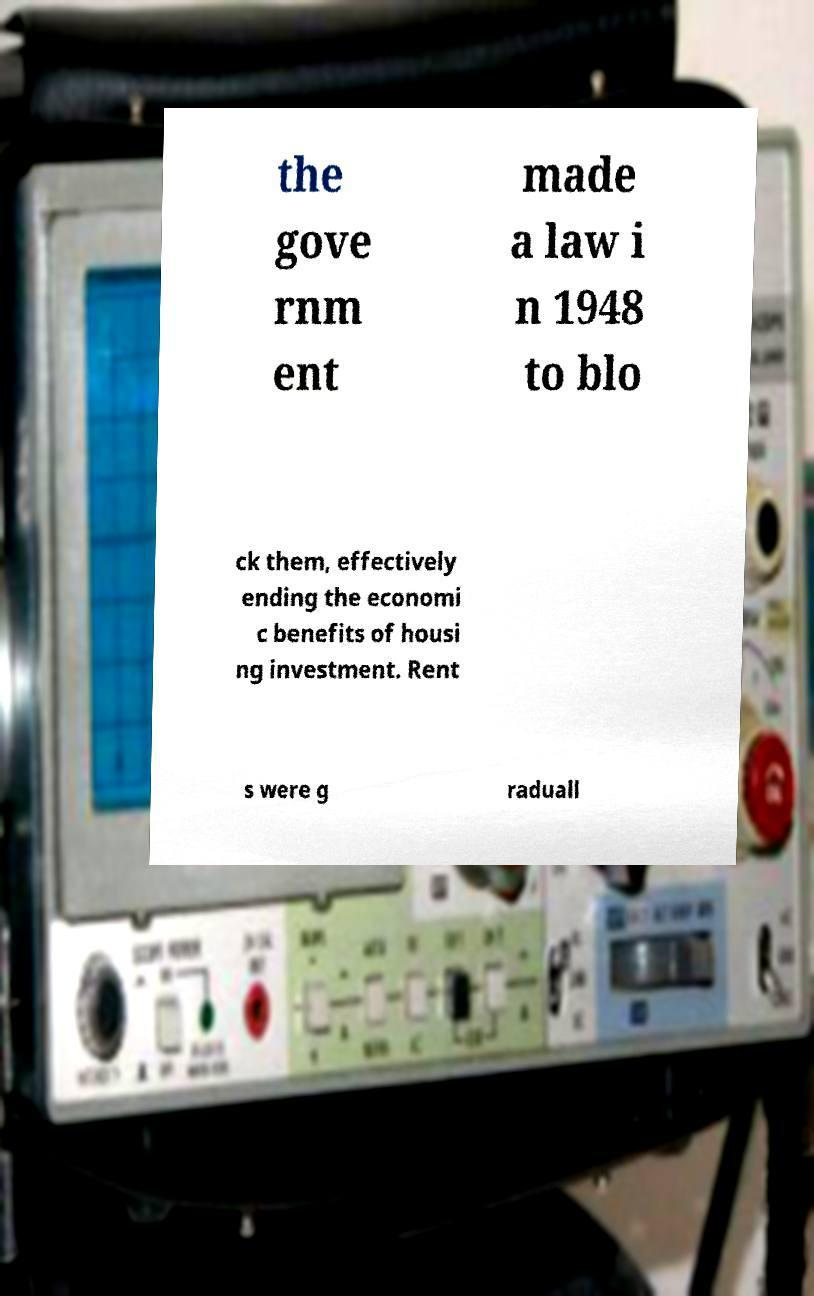Please read and relay the text visible in this image. What does it say? the gove rnm ent made a law i n 1948 to blo ck them, effectively ending the economi c benefits of housi ng investment. Rent s were g raduall 